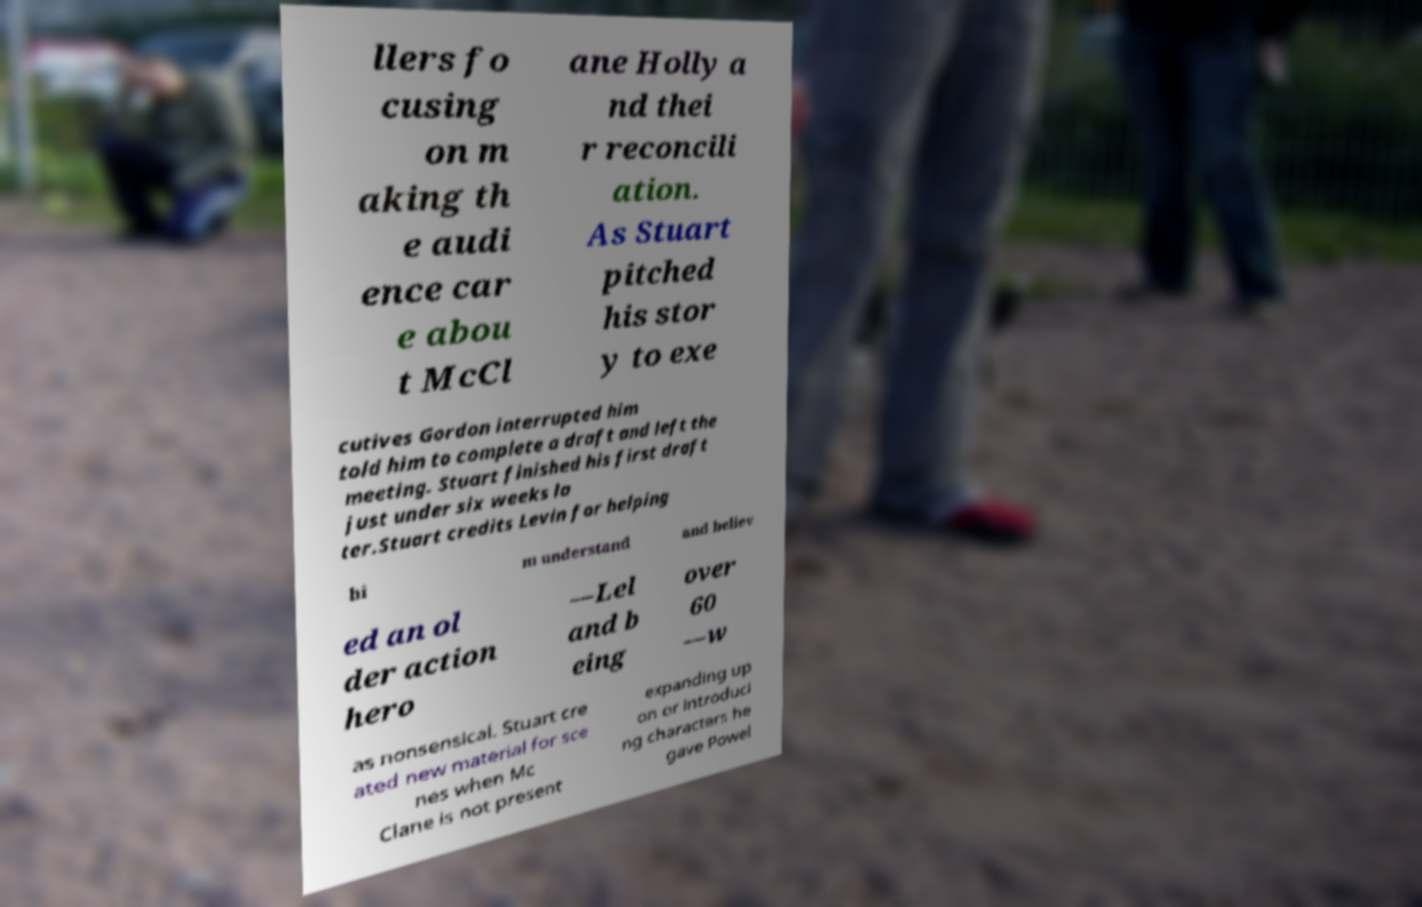Could you assist in decoding the text presented in this image and type it out clearly? llers fo cusing on m aking th e audi ence car e abou t McCl ane Holly a nd thei r reconcili ation. As Stuart pitched his stor y to exe cutives Gordon interrupted him told him to complete a draft and left the meeting. Stuart finished his first draft just under six weeks la ter.Stuart credits Levin for helping hi m understand and believ ed an ol der action hero —Lel and b eing over 60 —w as nonsensical. Stuart cre ated new material for sce nes when Mc Clane is not present expanding up on or introduci ng characters he gave Powel 